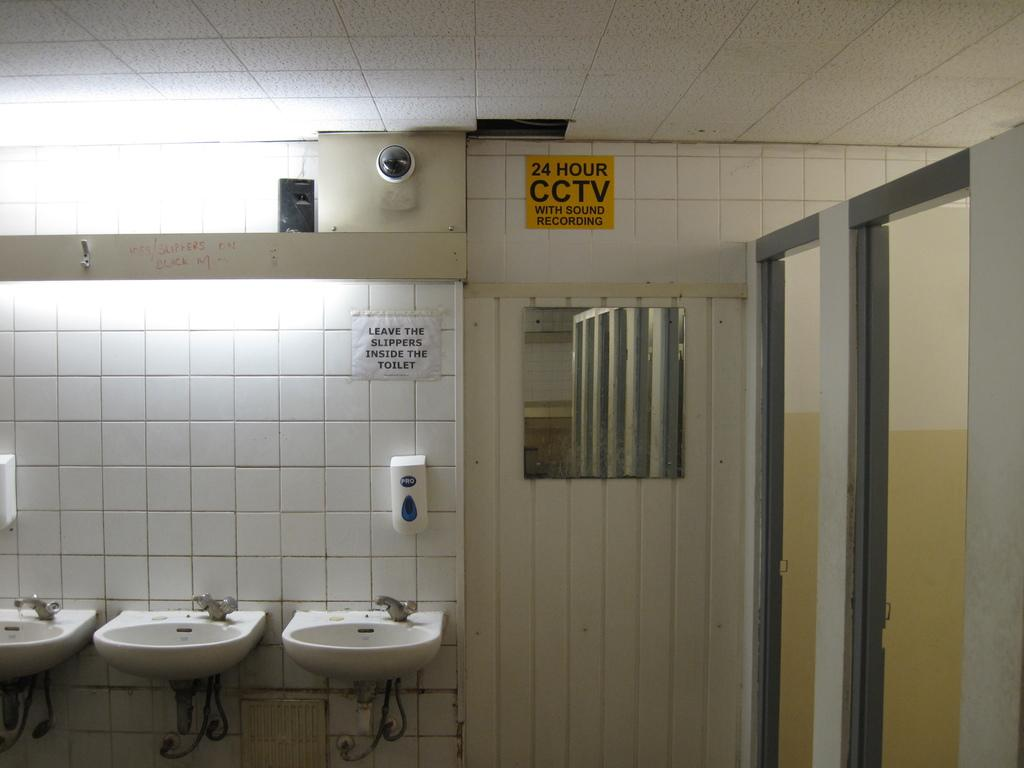What can be seen in the foreground of the image? In the foreground of the image, there are sinks, a wall, posters on the wall, white objects, a CCTV camera, a mirror, a ceiling, and two entrances. What is the purpose of the white objects in the foreground? The white objects in the foreground are not explicitly mentioned, but they could be sinks or other fixtures. What is depicted on the posters on the wall? The content of the posters on the wall is not mentioned in the facts, so we cannot determine what they depict. How many entrances are visible in the foreground of the image? There are two entrances visible in the foreground of the image. What type of milk is being poured into the sink in the image? There is no milk being poured into the sink in the image. Is there a window visible in the image? There is no mention of a window in the provided facts, so we cannot determine if one is present. 